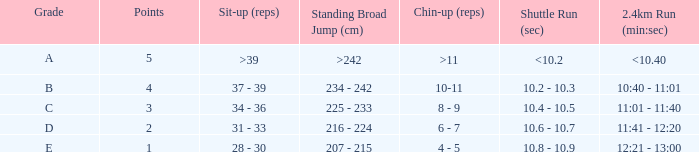Tell me the shuttle run with grade c 10.4 - 10.5. 